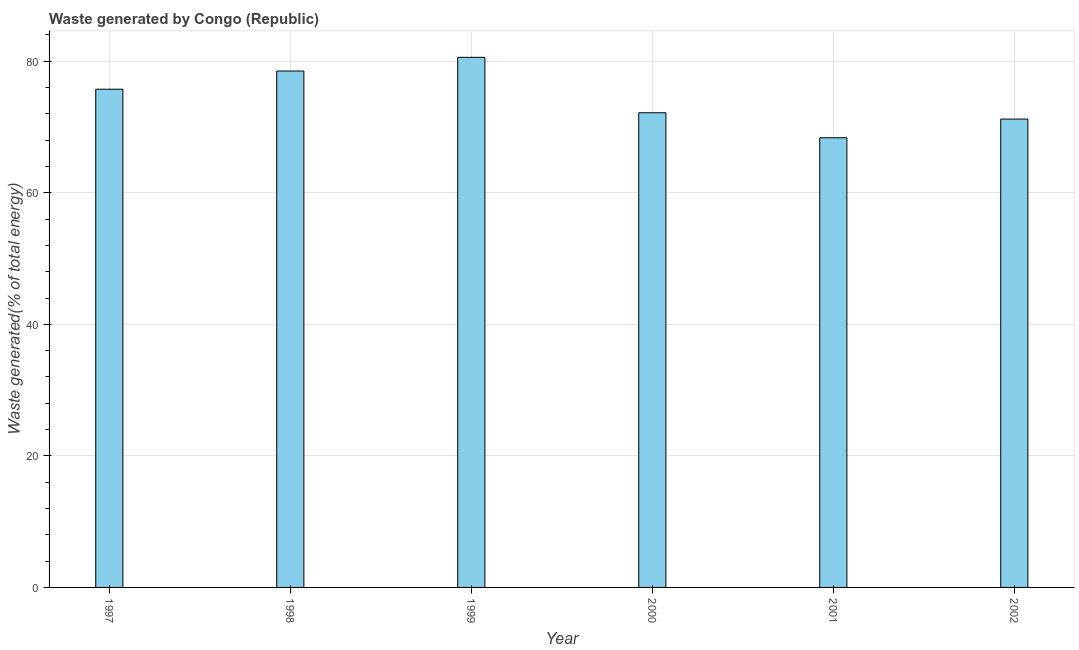Does the graph contain grids?
Offer a terse response. Yes. What is the title of the graph?
Offer a terse response. Waste generated by Congo (Republic). What is the label or title of the X-axis?
Offer a very short reply. Year. What is the label or title of the Y-axis?
Your answer should be very brief. Waste generated(% of total energy). What is the amount of waste generated in 2002?
Offer a terse response. 71.21. Across all years, what is the maximum amount of waste generated?
Keep it short and to the point. 80.6. Across all years, what is the minimum amount of waste generated?
Offer a very short reply. 68.36. In which year was the amount of waste generated maximum?
Your response must be concise. 1999. In which year was the amount of waste generated minimum?
Give a very brief answer. 2001. What is the sum of the amount of waste generated?
Provide a short and direct response. 446.59. What is the difference between the amount of waste generated in 1998 and 2000?
Keep it short and to the point. 6.35. What is the average amount of waste generated per year?
Offer a terse response. 74.43. What is the median amount of waste generated?
Your answer should be very brief. 73.96. What is the ratio of the amount of waste generated in 1998 to that in 2002?
Provide a short and direct response. 1.1. Is the amount of waste generated in 1997 less than that in 1998?
Offer a very short reply. Yes. Is the difference between the amount of waste generated in 1997 and 2000 greater than the difference between any two years?
Your answer should be very brief. No. What is the difference between the highest and the second highest amount of waste generated?
Provide a succinct answer. 2.08. Is the sum of the amount of waste generated in 1998 and 1999 greater than the maximum amount of waste generated across all years?
Offer a very short reply. Yes. What is the difference between the highest and the lowest amount of waste generated?
Offer a very short reply. 12.23. In how many years, is the amount of waste generated greater than the average amount of waste generated taken over all years?
Ensure brevity in your answer.  3. How many bars are there?
Provide a short and direct response. 6. Are all the bars in the graph horizontal?
Offer a terse response. No. What is the difference between two consecutive major ticks on the Y-axis?
Keep it short and to the point. 20. What is the Waste generated(% of total energy) in 1997?
Provide a short and direct response. 75.75. What is the Waste generated(% of total energy) of 1998?
Keep it short and to the point. 78.51. What is the Waste generated(% of total energy) of 1999?
Provide a succinct answer. 80.6. What is the Waste generated(% of total energy) in 2000?
Your answer should be compact. 72.17. What is the Waste generated(% of total energy) in 2001?
Your answer should be very brief. 68.36. What is the Waste generated(% of total energy) of 2002?
Give a very brief answer. 71.21. What is the difference between the Waste generated(% of total energy) in 1997 and 1998?
Ensure brevity in your answer.  -2.77. What is the difference between the Waste generated(% of total energy) in 1997 and 1999?
Provide a short and direct response. -4.85. What is the difference between the Waste generated(% of total energy) in 1997 and 2000?
Make the answer very short. 3.58. What is the difference between the Waste generated(% of total energy) in 1997 and 2001?
Offer a terse response. 7.38. What is the difference between the Waste generated(% of total energy) in 1997 and 2002?
Keep it short and to the point. 4.54. What is the difference between the Waste generated(% of total energy) in 1998 and 1999?
Provide a succinct answer. -2.08. What is the difference between the Waste generated(% of total energy) in 1998 and 2000?
Offer a terse response. 6.35. What is the difference between the Waste generated(% of total energy) in 1998 and 2001?
Your response must be concise. 10.15. What is the difference between the Waste generated(% of total energy) in 1998 and 2002?
Ensure brevity in your answer.  7.31. What is the difference between the Waste generated(% of total energy) in 1999 and 2000?
Your answer should be very brief. 8.43. What is the difference between the Waste generated(% of total energy) in 1999 and 2001?
Offer a terse response. 12.23. What is the difference between the Waste generated(% of total energy) in 1999 and 2002?
Your answer should be very brief. 9.39. What is the difference between the Waste generated(% of total energy) in 2000 and 2001?
Make the answer very short. 3.8. What is the difference between the Waste generated(% of total energy) in 2000 and 2002?
Your answer should be very brief. 0.96. What is the difference between the Waste generated(% of total energy) in 2001 and 2002?
Offer a very short reply. -2.84. What is the ratio of the Waste generated(% of total energy) in 1997 to that in 1998?
Provide a succinct answer. 0.96. What is the ratio of the Waste generated(% of total energy) in 1997 to that in 2001?
Your answer should be very brief. 1.11. What is the ratio of the Waste generated(% of total energy) in 1997 to that in 2002?
Your answer should be compact. 1.06. What is the ratio of the Waste generated(% of total energy) in 1998 to that in 1999?
Ensure brevity in your answer.  0.97. What is the ratio of the Waste generated(% of total energy) in 1998 to that in 2000?
Your response must be concise. 1.09. What is the ratio of the Waste generated(% of total energy) in 1998 to that in 2001?
Offer a terse response. 1.15. What is the ratio of the Waste generated(% of total energy) in 1998 to that in 2002?
Make the answer very short. 1.1. What is the ratio of the Waste generated(% of total energy) in 1999 to that in 2000?
Your answer should be compact. 1.12. What is the ratio of the Waste generated(% of total energy) in 1999 to that in 2001?
Provide a succinct answer. 1.18. What is the ratio of the Waste generated(% of total energy) in 1999 to that in 2002?
Make the answer very short. 1.13. What is the ratio of the Waste generated(% of total energy) in 2000 to that in 2001?
Make the answer very short. 1.06. What is the ratio of the Waste generated(% of total energy) in 2000 to that in 2002?
Provide a short and direct response. 1.01. What is the ratio of the Waste generated(% of total energy) in 2001 to that in 2002?
Offer a terse response. 0.96. 